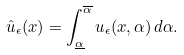<formula> <loc_0><loc_0><loc_500><loc_500>\hat { u } _ { \epsilon } ( x ) = \int _ { \underline { \alpha } } ^ { \overline { \alpha } } u _ { \epsilon } ( x , \alpha ) \, d \alpha .</formula> 